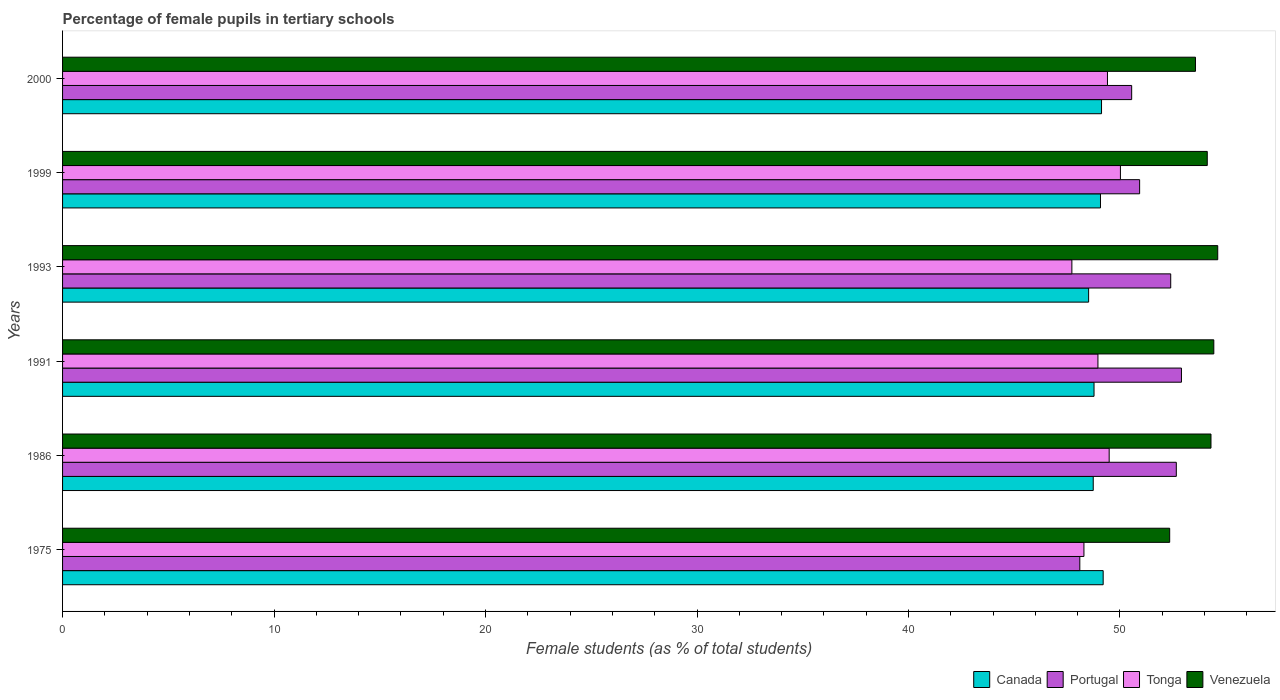How many bars are there on the 6th tick from the top?
Your answer should be compact. 4. How many bars are there on the 6th tick from the bottom?
Ensure brevity in your answer.  4. What is the label of the 4th group of bars from the top?
Provide a short and direct response. 1991. What is the percentage of female pupils in tertiary schools in Tonga in 1991?
Provide a succinct answer. 48.96. Across all years, what is the maximum percentage of female pupils in tertiary schools in Portugal?
Offer a terse response. 52.91. Across all years, what is the minimum percentage of female pupils in tertiary schools in Portugal?
Your answer should be very brief. 48.1. In which year was the percentage of female pupils in tertiary schools in Tonga maximum?
Give a very brief answer. 1999. In which year was the percentage of female pupils in tertiary schools in Tonga minimum?
Your answer should be very brief. 1993. What is the total percentage of female pupils in tertiary schools in Tonga in the graph?
Provide a succinct answer. 293.89. What is the difference between the percentage of female pupils in tertiary schools in Portugal in 1975 and that in 1991?
Make the answer very short. -4.81. What is the difference between the percentage of female pupils in tertiary schools in Tonga in 2000 and the percentage of female pupils in tertiary schools in Portugal in 1999?
Your answer should be compact. -1.52. What is the average percentage of female pupils in tertiary schools in Tonga per year?
Your answer should be compact. 48.98. In the year 1993, what is the difference between the percentage of female pupils in tertiary schools in Tonga and percentage of female pupils in tertiary schools in Canada?
Provide a short and direct response. -0.79. In how many years, is the percentage of female pupils in tertiary schools in Venezuela greater than 22 %?
Ensure brevity in your answer.  6. What is the ratio of the percentage of female pupils in tertiary schools in Portugal in 1991 to that in 1999?
Provide a succinct answer. 1.04. Is the percentage of female pupils in tertiary schools in Venezuela in 1975 less than that in 1991?
Provide a succinct answer. Yes. Is the difference between the percentage of female pupils in tertiary schools in Tonga in 1991 and 1993 greater than the difference between the percentage of female pupils in tertiary schools in Canada in 1991 and 1993?
Provide a succinct answer. Yes. What is the difference between the highest and the second highest percentage of female pupils in tertiary schools in Canada?
Ensure brevity in your answer.  0.08. What is the difference between the highest and the lowest percentage of female pupils in tertiary schools in Canada?
Keep it short and to the point. 0.69. Is the sum of the percentage of female pupils in tertiary schools in Venezuela in 1975 and 2000 greater than the maximum percentage of female pupils in tertiary schools in Canada across all years?
Your answer should be compact. Yes. Is it the case that in every year, the sum of the percentage of female pupils in tertiary schools in Portugal and percentage of female pupils in tertiary schools in Canada is greater than the sum of percentage of female pupils in tertiary schools in Venezuela and percentage of female pupils in tertiary schools in Tonga?
Give a very brief answer. Yes. What does the 2nd bar from the top in 2000 represents?
Offer a very short reply. Tonga. What does the 4th bar from the bottom in 1993 represents?
Offer a terse response. Venezuela. How many bars are there?
Keep it short and to the point. 24. What is the difference between two consecutive major ticks on the X-axis?
Your response must be concise. 10. Are the values on the major ticks of X-axis written in scientific E-notation?
Your answer should be compact. No. Does the graph contain grids?
Offer a very short reply. No. Where does the legend appear in the graph?
Provide a succinct answer. Bottom right. How many legend labels are there?
Your response must be concise. 4. What is the title of the graph?
Your answer should be very brief. Percentage of female pupils in tertiary schools. Does "South Africa" appear as one of the legend labels in the graph?
Your response must be concise. No. What is the label or title of the X-axis?
Offer a very short reply. Female students (as % of total students). What is the Female students (as % of total students) of Canada in 1975?
Provide a short and direct response. 49.21. What is the Female students (as % of total students) of Portugal in 1975?
Your answer should be very brief. 48.1. What is the Female students (as % of total students) in Tonga in 1975?
Ensure brevity in your answer.  48.3. What is the Female students (as % of total students) of Venezuela in 1975?
Keep it short and to the point. 52.35. What is the Female students (as % of total students) of Canada in 1986?
Ensure brevity in your answer.  48.74. What is the Female students (as % of total students) of Portugal in 1986?
Offer a terse response. 52.66. What is the Female students (as % of total students) of Tonga in 1986?
Your response must be concise. 49.49. What is the Female students (as % of total students) of Venezuela in 1986?
Provide a succinct answer. 54.3. What is the Female students (as % of total students) of Canada in 1991?
Offer a terse response. 48.77. What is the Female students (as % of total students) in Portugal in 1991?
Your answer should be compact. 52.91. What is the Female students (as % of total students) in Tonga in 1991?
Your response must be concise. 48.96. What is the Female students (as % of total students) in Venezuela in 1991?
Make the answer very short. 54.44. What is the Female students (as % of total students) of Canada in 1993?
Your answer should be very brief. 48.52. What is the Female students (as % of total students) in Portugal in 1993?
Keep it short and to the point. 52.4. What is the Female students (as % of total students) in Tonga in 1993?
Your answer should be very brief. 47.72. What is the Female students (as % of total students) of Venezuela in 1993?
Provide a succinct answer. 54.62. What is the Female students (as % of total students) in Canada in 1999?
Ensure brevity in your answer.  49.08. What is the Female students (as % of total students) in Portugal in 1999?
Offer a terse response. 50.93. What is the Female students (as % of total students) in Tonga in 1999?
Offer a very short reply. 50.02. What is the Female students (as % of total students) in Venezuela in 1999?
Keep it short and to the point. 54.13. What is the Female students (as % of total students) in Canada in 2000?
Offer a very short reply. 49.13. What is the Female students (as % of total students) of Portugal in 2000?
Provide a succinct answer. 50.55. What is the Female students (as % of total students) of Tonga in 2000?
Your answer should be very brief. 49.41. What is the Female students (as % of total students) of Venezuela in 2000?
Your answer should be very brief. 53.57. Across all years, what is the maximum Female students (as % of total students) in Canada?
Keep it short and to the point. 49.21. Across all years, what is the maximum Female students (as % of total students) of Portugal?
Give a very brief answer. 52.91. Across all years, what is the maximum Female students (as % of total students) of Tonga?
Give a very brief answer. 50.02. Across all years, what is the maximum Female students (as % of total students) of Venezuela?
Provide a short and direct response. 54.62. Across all years, what is the minimum Female students (as % of total students) of Canada?
Offer a terse response. 48.52. Across all years, what is the minimum Female students (as % of total students) of Portugal?
Offer a terse response. 48.1. Across all years, what is the minimum Female students (as % of total students) in Tonga?
Your answer should be compact. 47.72. Across all years, what is the minimum Female students (as % of total students) of Venezuela?
Give a very brief answer. 52.35. What is the total Female students (as % of total students) in Canada in the graph?
Your answer should be very brief. 293.44. What is the total Female students (as % of total students) in Portugal in the graph?
Provide a short and direct response. 307.55. What is the total Female students (as % of total students) in Tonga in the graph?
Provide a succinct answer. 293.89. What is the total Female students (as % of total students) of Venezuela in the graph?
Provide a succinct answer. 323.41. What is the difference between the Female students (as % of total students) in Canada in 1975 and that in 1986?
Offer a terse response. 0.47. What is the difference between the Female students (as % of total students) in Portugal in 1975 and that in 1986?
Provide a succinct answer. -4.56. What is the difference between the Female students (as % of total students) of Tonga in 1975 and that in 1986?
Ensure brevity in your answer.  -1.19. What is the difference between the Female students (as % of total students) in Venezuela in 1975 and that in 1986?
Make the answer very short. -1.95. What is the difference between the Female students (as % of total students) in Canada in 1975 and that in 1991?
Offer a terse response. 0.43. What is the difference between the Female students (as % of total students) of Portugal in 1975 and that in 1991?
Provide a succinct answer. -4.81. What is the difference between the Female students (as % of total students) of Tonga in 1975 and that in 1991?
Provide a succinct answer. -0.66. What is the difference between the Female students (as % of total students) in Venezuela in 1975 and that in 1991?
Give a very brief answer. -2.09. What is the difference between the Female students (as % of total students) in Canada in 1975 and that in 1993?
Offer a very short reply. 0.69. What is the difference between the Female students (as % of total students) of Portugal in 1975 and that in 1993?
Give a very brief answer. -4.3. What is the difference between the Female students (as % of total students) of Tonga in 1975 and that in 1993?
Offer a terse response. 0.57. What is the difference between the Female students (as % of total students) in Venezuela in 1975 and that in 1993?
Provide a short and direct response. -2.27. What is the difference between the Female students (as % of total students) of Canada in 1975 and that in 1999?
Your response must be concise. 0.13. What is the difference between the Female students (as % of total students) in Portugal in 1975 and that in 1999?
Provide a succinct answer. -2.83. What is the difference between the Female students (as % of total students) of Tonga in 1975 and that in 1999?
Ensure brevity in your answer.  -1.73. What is the difference between the Female students (as % of total students) in Venezuela in 1975 and that in 1999?
Your answer should be compact. -1.78. What is the difference between the Female students (as % of total students) in Canada in 1975 and that in 2000?
Offer a very short reply. 0.08. What is the difference between the Female students (as % of total students) of Portugal in 1975 and that in 2000?
Offer a terse response. -2.45. What is the difference between the Female students (as % of total students) of Tonga in 1975 and that in 2000?
Provide a short and direct response. -1.11. What is the difference between the Female students (as % of total students) of Venezuela in 1975 and that in 2000?
Make the answer very short. -1.22. What is the difference between the Female students (as % of total students) in Canada in 1986 and that in 1991?
Keep it short and to the point. -0.04. What is the difference between the Female students (as % of total students) in Portugal in 1986 and that in 1991?
Keep it short and to the point. -0.24. What is the difference between the Female students (as % of total students) in Tonga in 1986 and that in 1991?
Offer a terse response. 0.53. What is the difference between the Female students (as % of total students) of Venezuela in 1986 and that in 1991?
Give a very brief answer. -0.13. What is the difference between the Female students (as % of total students) of Canada in 1986 and that in 1993?
Your answer should be compact. 0.22. What is the difference between the Female students (as % of total students) in Portugal in 1986 and that in 1993?
Your answer should be compact. 0.26. What is the difference between the Female students (as % of total students) in Tonga in 1986 and that in 1993?
Make the answer very short. 1.76. What is the difference between the Female students (as % of total students) of Venezuela in 1986 and that in 1993?
Offer a terse response. -0.32. What is the difference between the Female students (as % of total students) of Canada in 1986 and that in 1999?
Your response must be concise. -0.34. What is the difference between the Female students (as % of total students) of Portugal in 1986 and that in 1999?
Keep it short and to the point. 1.73. What is the difference between the Female students (as % of total students) in Tonga in 1986 and that in 1999?
Your answer should be very brief. -0.53. What is the difference between the Female students (as % of total students) in Venezuela in 1986 and that in 1999?
Give a very brief answer. 0.18. What is the difference between the Female students (as % of total students) of Canada in 1986 and that in 2000?
Provide a short and direct response. -0.39. What is the difference between the Female students (as % of total students) of Portugal in 1986 and that in 2000?
Offer a terse response. 2.11. What is the difference between the Female students (as % of total students) in Tonga in 1986 and that in 2000?
Provide a succinct answer. 0.08. What is the difference between the Female students (as % of total students) in Venezuela in 1986 and that in 2000?
Offer a very short reply. 0.73. What is the difference between the Female students (as % of total students) of Canada in 1991 and that in 1993?
Your answer should be very brief. 0.26. What is the difference between the Female students (as % of total students) of Portugal in 1991 and that in 1993?
Give a very brief answer. 0.51. What is the difference between the Female students (as % of total students) of Tonga in 1991 and that in 1993?
Your answer should be compact. 1.23. What is the difference between the Female students (as % of total students) in Venezuela in 1991 and that in 1993?
Provide a short and direct response. -0.19. What is the difference between the Female students (as % of total students) in Canada in 1991 and that in 1999?
Offer a very short reply. -0.3. What is the difference between the Female students (as % of total students) in Portugal in 1991 and that in 1999?
Offer a terse response. 1.98. What is the difference between the Female students (as % of total students) in Tonga in 1991 and that in 1999?
Your answer should be compact. -1.06. What is the difference between the Female students (as % of total students) of Venezuela in 1991 and that in 1999?
Offer a very short reply. 0.31. What is the difference between the Female students (as % of total students) of Canada in 1991 and that in 2000?
Keep it short and to the point. -0.36. What is the difference between the Female students (as % of total students) of Portugal in 1991 and that in 2000?
Your answer should be very brief. 2.35. What is the difference between the Female students (as % of total students) of Tonga in 1991 and that in 2000?
Give a very brief answer. -0.45. What is the difference between the Female students (as % of total students) in Venezuela in 1991 and that in 2000?
Give a very brief answer. 0.87. What is the difference between the Female students (as % of total students) in Canada in 1993 and that in 1999?
Offer a terse response. -0.56. What is the difference between the Female students (as % of total students) in Portugal in 1993 and that in 1999?
Provide a short and direct response. 1.47. What is the difference between the Female students (as % of total students) of Tonga in 1993 and that in 1999?
Your answer should be compact. -2.3. What is the difference between the Female students (as % of total students) in Venezuela in 1993 and that in 1999?
Keep it short and to the point. 0.49. What is the difference between the Female students (as % of total students) of Canada in 1993 and that in 2000?
Ensure brevity in your answer.  -0.61. What is the difference between the Female students (as % of total students) in Portugal in 1993 and that in 2000?
Offer a terse response. 1.85. What is the difference between the Female students (as % of total students) of Tonga in 1993 and that in 2000?
Ensure brevity in your answer.  -1.68. What is the difference between the Female students (as % of total students) in Venezuela in 1993 and that in 2000?
Offer a terse response. 1.05. What is the difference between the Female students (as % of total students) of Canada in 1999 and that in 2000?
Offer a very short reply. -0.05. What is the difference between the Female students (as % of total students) of Portugal in 1999 and that in 2000?
Ensure brevity in your answer.  0.38. What is the difference between the Female students (as % of total students) of Tonga in 1999 and that in 2000?
Keep it short and to the point. 0.61. What is the difference between the Female students (as % of total students) in Venezuela in 1999 and that in 2000?
Ensure brevity in your answer.  0.56. What is the difference between the Female students (as % of total students) of Canada in 1975 and the Female students (as % of total students) of Portugal in 1986?
Provide a succinct answer. -3.46. What is the difference between the Female students (as % of total students) of Canada in 1975 and the Female students (as % of total students) of Tonga in 1986?
Your answer should be very brief. -0.28. What is the difference between the Female students (as % of total students) in Canada in 1975 and the Female students (as % of total students) in Venezuela in 1986?
Your response must be concise. -5.1. What is the difference between the Female students (as % of total students) of Portugal in 1975 and the Female students (as % of total students) of Tonga in 1986?
Your response must be concise. -1.39. What is the difference between the Female students (as % of total students) of Portugal in 1975 and the Female students (as % of total students) of Venezuela in 1986?
Your answer should be compact. -6.2. What is the difference between the Female students (as % of total students) in Tonga in 1975 and the Female students (as % of total students) in Venezuela in 1986?
Provide a short and direct response. -6.01. What is the difference between the Female students (as % of total students) of Canada in 1975 and the Female students (as % of total students) of Portugal in 1991?
Ensure brevity in your answer.  -3.7. What is the difference between the Female students (as % of total students) in Canada in 1975 and the Female students (as % of total students) in Tonga in 1991?
Give a very brief answer. 0.25. What is the difference between the Female students (as % of total students) of Canada in 1975 and the Female students (as % of total students) of Venezuela in 1991?
Your answer should be very brief. -5.23. What is the difference between the Female students (as % of total students) in Portugal in 1975 and the Female students (as % of total students) in Tonga in 1991?
Provide a short and direct response. -0.86. What is the difference between the Female students (as % of total students) of Portugal in 1975 and the Female students (as % of total students) of Venezuela in 1991?
Ensure brevity in your answer.  -6.34. What is the difference between the Female students (as % of total students) of Tonga in 1975 and the Female students (as % of total students) of Venezuela in 1991?
Ensure brevity in your answer.  -6.14. What is the difference between the Female students (as % of total students) in Canada in 1975 and the Female students (as % of total students) in Portugal in 1993?
Give a very brief answer. -3.19. What is the difference between the Female students (as % of total students) of Canada in 1975 and the Female students (as % of total students) of Tonga in 1993?
Make the answer very short. 1.48. What is the difference between the Female students (as % of total students) in Canada in 1975 and the Female students (as % of total students) in Venezuela in 1993?
Give a very brief answer. -5.42. What is the difference between the Female students (as % of total students) of Portugal in 1975 and the Female students (as % of total students) of Tonga in 1993?
Give a very brief answer. 0.38. What is the difference between the Female students (as % of total students) of Portugal in 1975 and the Female students (as % of total students) of Venezuela in 1993?
Give a very brief answer. -6.52. What is the difference between the Female students (as % of total students) in Tonga in 1975 and the Female students (as % of total students) in Venezuela in 1993?
Keep it short and to the point. -6.33. What is the difference between the Female students (as % of total students) in Canada in 1975 and the Female students (as % of total students) in Portugal in 1999?
Offer a terse response. -1.72. What is the difference between the Female students (as % of total students) of Canada in 1975 and the Female students (as % of total students) of Tonga in 1999?
Provide a succinct answer. -0.81. What is the difference between the Female students (as % of total students) in Canada in 1975 and the Female students (as % of total students) in Venezuela in 1999?
Keep it short and to the point. -4.92. What is the difference between the Female students (as % of total students) of Portugal in 1975 and the Female students (as % of total students) of Tonga in 1999?
Offer a terse response. -1.92. What is the difference between the Female students (as % of total students) in Portugal in 1975 and the Female students (as % of total students) in Venezuela in 1999?
Your response must be concise. -6.03. What is the difference between the Female students (as % of total students) of Tonga in 1975 and the Female students (as % of total students) of Venezuela in 1999?
Keep it short and to the point. -5.83. What is the difference between the Female students (as % of total students) of Canada in 1975 and the Female students (as % of total students) of Portugal in 2000?
Give a very brief answer. -1.35. What is the difference between the Female students (as % of total students) of Canada in 1975 and the Female students (as % of total students) of Tonga in 2000?
Your answer should be compact. -0.2. What is the difference between the Female students (as % of total students) of Canada in 1975 and the Female students (as % of total students) of Venezuela in 2000?
Offer a terse response. -4.36. What is the difference between the Female students (as % of total students) in Portugal in 1975 and the Female students (as % of total students) in Tonga in 2000?
Your answer should be compact. -1.31. What is the difference between the Female students (as % of total students) in Portugal in 1975 and the Female students (as % of total students) in Venezuela in 2000?
Your response must be concise. -5.47. What is the difference between the Female students (as % of total students) of Tonga in 1975 and the Female students (as % of total students) of Venezuela in 2000?
Ensure brevity in your answer.  -5.27. What is the difference between the Female students (as % of total students) of Canada in 1986 and the Female students (as % of total students) of Portugal in 1991?
Keep it short and to the point. -4.17. What is the difference between the Female students (as % of total students) in Canada in 1986 and the Female students (as % of total students) in Tonga in 1991?
Your answer should be very brief. -0.22. What is the difference between the Female students (as % of total students) in Canada in 1986 and the Female students (as % of total students) in Venezuela in 1991?
Keep it short and to the point. -5.7. What is the difference between the Female students (as % of total students) in Portugal in 1986 and the Female students (as % of total students) in Tonga in 1991?
Provide a short and direct response. 3.71. What is the difference between the Female students (as % of total students) of Portugal in 1986 and the Female students (as % of total students) of Venezuela in 1991?
Offer a very short reply. -1.77. What is the difference between the Female students (as % of total students) of Tonga in 1986 and the Female students (as % of total students) of Venezuela in 1991?
Your response must be concise. -4.95. What is the difference between the Female students (as % of total students) of Canada in 1986 and the Female students (as % of total students) of Portugal in 1993?
Your answer should be compact. -3.66. What is the difference between the Female students (as % of total students) of Canada in 1986 and the Female students (as % of total students) of Tonga in 1993?
Offer a very short reply. 1.01. What is the difference between the Female students (as % of total students) of Canada in 1986 and the Female students (as % of total students) of Venezuela in 1993?
Your answer should be compact. -5.89. What is the difference between the Female students (as % of total students) in Portugal in 1986 and the Female students (as % of total students) in Tonga in 1993?
Provide a short and direct response. 4.94. What is the difference between the Female students (as % of total students) in Portugal in 1986 and the Female students (as % of total students) in Venezuela in 1993?
Give a very brief answer. -1.96. What is the difference between the Female students (as % of total students) in Tonga in 1986 and the Female students (as % of total students) in Venezuela in 1993?
Your answer should be compact. -5.13. What is the difference between the Female students (as % of total students) in Canada in 1986 and the Female students (as % of total students) in Portugal in 1999?
Make the answer very short. -2.19. What is the difference between the Female students (as % of total students) of Canada in 1986 and the Female students (as % of total students) of Tonga in 1999?
Offer a very short reply. -1.29. What is the difference between the Female students (as % of total students) of Canada in 1986 and the Female students (as % of total students) of Venezuela in 1999?
Make the answer very short. -5.39. What is the difference between the Female students (as % of total students) in Portugal in 1986 and the Female students (as % of total students) in Tonga in 1999?
Offer a terse response. 2.64. What is the difference between the Female students (as % of total students) in Portugal in 1986 and the Female students (as % of total students) in Venezuela in 1999?
Make the answer very short. -1.46. What is the difference between the Female students (as % of total students) in Tonga in 1986 and the Female students (as % of total students) in Venezuela in 1999?
Offer a terse response. -4.64. What is the difference between the Female students (as % of total students) of Canada in 1986 and the Female students (as % of total students) of Portugal in 2000?
Offer a very short reply. -1.82. What is the difference between the Female students (as % of total students) in Canada in 1986 and the Female students (as % of total students) in Tonga in 2000?
Keep it short and to the point. -0.67. What is the difference between the Female students (as % of total students) of Canada in 1986 and the Female students (as % of total students) of Venezuela in 2000?
Your answer should be very brief. -4.83. What is the difference between the Female students (as % of total students) in Portugal in 1986 and the Female students (as % of total students) in Tonga in 2000?
Keep it short and to the point. 3.26. What is the difference between the Female students (as % of total students) in Portugal in 1986 and the Female students (as % of total students) in Venezuela in 2000?
Ensure brevity in your answer.  -0.91. What is the difference between the Female students (as % of total students) in Tonga in 1986 and the Female students (as % of total students) in Venezuela in 2000?
Provide a short and direct response. -4.08. What is the difference between the Female students (as % of total students) of Canada in 1991 and the Female students (as % of total students) of Portugal in 1993?
Make the answer very short. -3.63. What is the difference between the Female students (as % of total students) in Canada in 1991 and the Female students (as % of total students) in Tonga in 1993?
Offer a very short reply. 1.05. What is the difference between the Female students (as % of total students) in Canada in 1991 and the Female students (as % of total students) in Venezuela in 1993?
Provide a short and direct response. -5.85. What is the difference between the Female students (as % of total students) of Portugal in 1991 and the Female students (as % of total students) of Tonga in 1993?
Keep it short and to the point. 5.18. What is the difference between the Female students (as % of total students) of Portugal in 1991 and the Female students (as % of total students) of Venezuela in 1993?
Make the answer very short. -1.72. What is the difference between the Female students (as % of total students) of Tonga in 1991 and the Female students (as % of total students) of Venezuela in 1993?
Make the answer very short. -5.66. What is the difference between the Female students (as % of total students) of Canada in 1991 and the Female students (as % of total students) of Portugal in 1999?
Ensure brevity in your answer.  -2.16. What is the difference between the Female students (as % of total students) of Canada in 1991 and the Female students (as % of total students) of Tonga in 1999?
Keep it short and to the point. -1.25. What is the difference between the Female students (as % of total students) in Canada in 1991 and the Female students (as % of total students) in Venezuela in 1999?
Provide a short and direct response. -5.35. What is the difference between the Female students (as % of total students) in Portugal in 1991 and the Female students (as % of total students) in Tonga in 1999?
Your answer should be very brief. 2.89. What is the difference between the Female students (as % of total students) of Portugal in 1991 and the Female students (as % of total students) of Venezuela in 1999?
Your answer should be very brief. -1.22. What is the difference between the Female students (as % of total students) in Tonga in 1991 and the Female students (as % of total students) in Venezuela in 1999?
Your answer should be compact. -5.17. What is the difference between the Female students (as % of total students) of Canada in 1991 and the Female students (as % of total students) of Portugal in 2000?
Ensure brevity in your answer.  -1.78. What is the difference between the Female students (as % of total students) of Canada in 1991 and the Female students (as % of total students) of Tonga in 2000?
Your answer should be very brief. -0.64. What is the difference between the Female students (as % of total students) in Canada in 1991 and the Female students (as % of total students) in Venezuela in 2000?
Your answer should be very brief. -4.8. What is the difference between the Female students (as % of total students) of Portugal in 1991 and the Female students (as % of total students) of Tonga in 2000?
Provide a succinct answer. 3.5. What is the difference between the Female students (as % of total students) in Portugal in 1991 and the Female students (as % of total students) in Venezuela in 2000?
Your response must be concise. -0.66. What is the difference between the Female students (as % of total students) of Tonga in 1991 and the Female students (as % of total students) of Venezuela in 2000?
Provide a succinct answer. -4.61. What is the difference between the Female students (as % of total students) in Canada in 1993 and the Female students (as % of total students) in Portugal in 1999?
Give a very brief answer. -2.41. What is the difference between the Female students (as % of total students) of Canada in 1993 and the Female students (as % of total students) of Tonga in 1999?
Your response must be concise. -1.5. What is the difference between the Female students (as % of total students) in Canada in 1993 and the Female students (as % of total students) in Venezuela in 1999?
Keep it short and to the point. -5.61. What is the difference between the Female students (as % of total students) of Portugal in 1993 and the Female students (as % of total students) of Tonga in 1999?
Your response must be concise. 2.38. What is the difference between the Female students (as % of total students) in Portugal in 1993 and the Female students (as % of total students) in Venezuela in 1999?
Your answer should be very brief. -1.73. What is the difference between the Female students (as % of total students) of Tonga in 1993 and the Female students (as % of total students) of Venezuela in 1999?
Your answer should be very brief. -6.4. What is the difference between the Female students (as % of total students) of Canada in 1993 and the Female students (as % of total students) of Portugal in 2000?
Your answer should be compact. -2.03. What is the difference between the Female students (as % of total students) in Canada in 1993 and the Female students (as % of total students) in Tonga in 2000?
Provide a succinct answer. -0.89. What is the difference between the Female students (as % of total students) of Canada in 1993 and the Female students (as % of total students) of Venezuela in 2000?
Provide a short and direct response. -5.05. What is the difference between the Female students (as % of total students) in Portugal in 1993 and the Female students (as % of total students) in Tonga in 2000?
Provide a short and direct response. 2.99. What is the difference between the Female students (as % of total students) of Portugal in 1993 and the Female students (as % of total students) of Venezuela in 2000?
Give a very brief answer. -1.17. What is the difference between the Female students (as % of total students) of Tonga in 1993 and the Female students (as % of total students) of Venezuela in 2000?
Your answer should be compact. -5.84. What is the difference between the Female students (as % of total students) in Canada in 1999 and the Female students (as % of total students) in Portugal in 2000?
Your answer should be very brief. -1.47. What is the difference between the Female students (as % of total students) in Canada in 1999 and the Female students (as % of total students) in Tonga in 2000?
Your answer should be very brief. -0.33. What is the difference between the Female students (as % of total students) of Canada in 1999 and the Female students (as % of total students) of Venezuela in 2000?
Offer a terse response. -4.49. What is the difference between the Female students (as % of total students) of Portugal in 1999 and the Female students (as % of total students) of Tonga in 2000?
Offer a terse response. 1.52. What is the difference between the Female students (as % of total students) in Portugal in 1999 and the Female students (as % of total students) in Venezuela in 2000?
Offer a very short reply. -2.64. What is the difference between the Female students (as % of total students) of Tonga in 1999 and the Female students (as % of total students) of Venezuela in 2000?
Keep it short and to the point. -3.55. What is the average Female students (as % of total students) of Canada per year?
Your response must be concise. 48.91. What is the average Female students (as % of total students) of Portugal per year?
Provide a succinct answer. 51.26. What is the average Female students (as % of total students) in Tonga per year?
Provide a short and direct response. 48.98. What is the average Female students (as % of total students) of Venezuela per year?
Offer a very short reply. 53.9. In the year 1975, what is the difference between the Female students (as % of total students) of Canada and Female students (as % of total students) of Portugal?
Make the answer very short. 1.1. In the year 1975, what is the difference between the Female students (as % of total students) of Canada and Female students (as % of total students) of Tonga?
Ensure brevity in your answer.  0.91. In the year 1975, what is the difference between the Female students (as % of total students) of Canada and Female students (as % of total students) of Venezuela?
Ensure brevity in your answer.  -3.14. In the year 1975, what is the difference between the Female students (as % of total students) of Portugal and Female students (as % of total students) of Tonga?
Your answer should be very brief. -0.2. In the year 1975, what is the difference between the Female students (as % of total students) in Portugal and Female students (as % of total students) in Venezuela?
Offer a very short reply. -4.25. In the year 1975, what is the difference between the Female students (as % of total students) of Tonga and Female students (as % of total students) of Venezuela?
Keep it short and to the point. -4.05. In the year 1986, what is the difference between the Female students (as % of total students) in Canada and Female students (as % of total students) in Portugal?
Keep it short and to the point. -3.93. In the year 1986, what is the difference between the Female students (as % of total students) in Canada and Female students (as % of total students) in Tonga?
Give a very brief answer. -0.75. In the year 1986, what is the difference between the Female students (as % of total students) in Canada and Female students (as % of total students) in Venezuela?
Your answer should be compact. -5.57. In the year 1986, what is the difference between the Female students (as % of total students) in Portugal and Female students (as % of total students) in Tonga?
Provide a succinct answer. 3.17. In the year 1986, what is the difference between the Female students (as % of total students) of Portugal and Female students (as % of total students) of Venezuela?
Provide a short and direct response. -1.64. In the year 1986, what is the difference between the Female students (as % of total students) in Tonga and Female students (as % of total students) in Venezuela?
Keep it short and to the point. -4.81. In the year 1991, what is the difference between the Female students (as % of total students) in Canada and Female students (as % of total students) in Portugal?
Offer a very short reply. -4.13. In the year 1991, what is the difference between the Female students (as % of total students) in Canada and Female students (as % of total students) in Tonga?
Make the answer very short. -0.19. In the year 1991, what is the difference between the Female students (as % of total students) in Canada and Female students (as % of total students) in Venezuela?
Keep it short and to the point. -5.66. In the year 1991, what is the difference between the Female students (as % of total students) of Portugal and Female students (as % of total students) of Tonga?
Your answer should be very brief. 3.95. In the year 1991, what is the difference between the Female students (as % of total students) in Portugal and Female students (as % of total students) in Venezuela?
Keep it short and to the point. -1.53. In the year 1991, what is the difference between the Female students (as % of total students) in Tonga and Female students (as % of total students) in Venezuela?
Provide a succinct answer. -5.48. In the year 1993, what is the difference between the Female students (as % of total students) of Canada and Female students (as % of total students) of Portugal?
Give a very brief answer. -3.88. In the year 1993, what is the difference between the Female students (as % of total students) in Canada and Female students (as % of total students) in Tonga?
Provide a succinct answer. 0.79. In the year 1993, what is the difference between the Female students (as % of total students) of Canada and Female students (as % of total students) of Venezuela?
Give a very brief answer. -6.1. In the year 1993, what is the difference between the Female students (as % of total students) in Portugal and Female students (as % of total students) in Tonga?
Offer a terse response. 4.67. In the year 1993, what is the difference between the Female students (as % of total students) of Portugal and Female students (as % of total students) of Venezuela?
Keep it short and to the point. -2.22. In the year 1993, what is the difference between the Female students (as % of total students) of Tonga and Female students (as % of total students) of Venezuela?
Your response must be concise. -6.9. In the year 1999, what is the difference between the Female students (as % of total students) in Canada and Female students (as % of total students) in Portugal?
Offer a very short reply. -1.85. In the year 1999, what is the difference between the Female students (as % of total students) of Canada and Female students (as % of total students) of Tonga?
Give a very brief answer. -0.94. In the year 1999, what is the difference between the Female students (as % of total students) in Canada and Female students (as % of total students) in Venezuela?
Provide a succinct answer. -5.05. In the year 1999, what is the difference between the Female students (as % of total students) in Portugal and Female students (as % of total students) in Tonga?
Give a very brief answer. 0.91. In the year 1999, what is the difference between the Female students (as % of total students) in Portugal and Female students (as % of total students) in Venezuela?
Make the answer very short. -3.2. In the year 1999, what is the difference between the Female students (as % of total students) of Tonga and Female students (as % of total students) of Venezuela?
Give a very brief answer. -4.11. In the year 2000, what is the difference between the Female students (as % of total students) of Canada and Female students (as % of total students) of Portugal?
Your answer should be compact. -1.42. In the year 2000, what is the difference between the Female students (as % of total students) in Canada and Female students (as % of total students) in Tonga?
Make the answer very short. -0.28. In the year 2000, what is the difference between the Female students (as % of total students) in Canada and Female students (as % of total students) in Venezuela?
Keep it short and to the point. -4.44. In the year 2000, what is the difference between the Female students (as % of total students) of Portugal and Female students (as % of total students) of Tonga?
Your answer should be very brief. 1.14. In the year 2000, what is the difference between the Female students (as % of total students) in Portugal and Female students (as % of total students) in Venezuela?
Make the answer very short. -3.02. In the year 2000, what is the difference between the Female students (as % of total students) of Tonga and Female students (as % of total students) of Venezuela?
Provide a short and direct response. -4.16. What is the ratio of the Female students (as % of total students) of Canada in 1975 to that in 1986?
Ensure brevity in your answer.  1.01. What is the ratio of the Female students (as % of total students) in Portugal in 1975 to that in 1986?
Your answer should be very brief. 0.91. What is the ratio of the Female students (as % of total students) in Tonga in 1975 to that in 1986?
Your answer should be very brief. 0.98. What is the ratio of the Female students (as % of total students) of Canada in 1975 to that in 1991?
Your response must be concise. 1.01. What is the ratio of the Female students (as % of total students) of Portugal in 1975 to that in 1991?
Your answer should be compact. 0.91. What is the ratio of the Female students (as % of total students) in Tonga in 1975 to that in 1991?
Your response must be concise. 0.99. What is the ratio of the Female students (as % of total students) in Venezuela in 1975 to that in 1991?
Give a very brief answer. 0.96. What is the ratio of the Female students (as % of total students) in Canada in 1975 to that in 1993?
Offer a terse response. 1.01. What is the ratio of the Female students (as % of total students) of Portugal in 1975 to that in 1993?
Offer a terse response. 0.92. What is the ratio of the Female students (as % of total students) in Tonga in 1975 to that in 1993?
Offer a terse response. 1.01. What is the ratio of the Female students (as % of total students) in Venezuela in 1975 to that in 1993?
Your answer should be very brief. 0.96. What is the ratio of the Female students (as % of total students) in Portugal in 1975 to that in 1999?
Make the answer very short. 0.94. What is the ratio of the Female students (as % of total students) of Tonga in 1975 to that in 1999?
Your response must be concise. 0.97. What is the ratio of the Female students (as % of total students) of Venezuela in 1975 to that in 1999?
Offer a very short reply. 0.97. What is the ratio of the Female students (as % of total students) of Portugal in 1975 to that in 2000?
Your response must be concise. 0.95. What is the ratio of the Female students (as % of total students) of Tonga in 1975 to that in 2000?
Make the answer very short. 0.98. What is the ratio of the Female students (as % of total students) of Venezuela in 1975 to that in 2000?
Offer a terse response. 0.98. What is the ratio of the Female students (as % of total students) of Tonga in 1986 to that in 1991?
Provide a short and direct response. 1.01. What is the ratio of the Female students (as % of total students) of Portugal in 1986 to that in 1993?
Offer a very short reply. 1. What is the ratio of the Female students (as % of total students) of Canada in 1986 to that in 1999?
Your answer should be very brief. 0.99. What is the ratio of the Female students (as % of total students) of Portugal in 1986 to that in 1999?
Provide a succinct answer. 1.03. What is the ratio of the Female students (as % of total students) of Tonga in 1986 to that in 1999?
Provide a succinct answer. 0.99. What is the ratio of the Female students (as % of total students) of Portugal in 1986 to that in 2000?
Your answer should be very brief. 1.04. What is the ratio of the Female students (as % of total students) of Tonga in 1986 to that in 2000?
Your answer should be very brief. 1. What is the ratio of the Female students (as % of total students) of Venezuela in 1986 to that in 2000?
Ensure brevity in your answer.  1.01. What is the ratio of the Female students (as % of total students) in Portugal in 1991 to that in 1993?
Provide a succinct answer. 1.01. What is the ratio of the Female students (as % of total students) of Tonga in 1991 to that in 1993?
Keep it short and to the point. 1.03. What is the ratio of the Female students (as % of total students) in Venezuela in 1991 to that in 1993?
Your response must be concise. 1. What is the ratio of the Female students (as % of total students) in Canada in 1991 to that in 1999?
Offer a very short reply. 0.99. What is the ratio of the Female students (as % of total students) of Portugal in 1991 to that in 1999?
Your answer should be very brief. 1.04. What is the ratio of the Female students (as % of total students) in Tonga in 1991 to that in 1999?
Your answer should be compact. 0.98. What is the ratio of the Female students (as % of total students) in Portugal in 1991 to that in 2000?
Provide a short and direct response. 1.05. What is the ratio of the Female students (as % of total students) of Tonga in 1991 to that in 2000?
Provide a short and direct response. 0.99. What is the ratio of the Female students (as % of total students) of Venezuela in 1991 to that in 2000?
Offer a very short reply. 1.02. What is the ratio of the Female students (as % of total students) in Portugal in 1993 to that in 1999?
Your answer should be compact. 1.03. What is the ratio of the Female students (as % of total students) of Tonga in 1993 to that in 1999?
Provide a short and direct response. 0.95. What is the ratio of the Female students (as % of total students) in Venezuela in 1993 to that in 1999?
Provide a short and direct response. 1.01. What is the ratio of the Female students (as % of total students) in Canada in 1993 to that in 2000?
Your response must be concise. 0.99. What is the ratio of the Female students (as % of total students) in Portugal in 1993 to that in 2000?
Offer a terse response. 1.04. What is the ratio of the Female students (as % of total students) of Tonga in 1993 to that in 2000?
Make the answer very short. 0.97. What is the ratio of the Female students (as % of total students) in Venezuela in 1993 to that in 2000?
Make the answer very short. 1.02. What is the ratio of the Female students (as % of total students) of Portugal in 1999 to that in 2000?
Offer a terse response. 1.01. What is the ratio of the Female students (as % of total students) of Tonga in 1999 to that in 2000?
Your response must be concise. 1.01. What is the ratio of the Female students (as % of total students) in Venezuela in 1999 to that in 2000?
Keep it short and to the point. 1.01. What is the difference between the highest and the second highest Female students (as % of total students) in Canada?
Provide a short and direct response. 0.08. What is the difference between the highest and the second highest Female students (as % of total students) of Portugal?
Offer a very short reply. 0.24. What is the difference between the highest and the second highest Female students (as % of total students) of Tonga?
Offer a very short reply. 0.53. What is the difference between the highest and the second highest Female students (as % of total students) in Venezuela?
Keep it short and to the point. 0.19. What is the difference between the highest and the lowest Female students (as % of total students) in Canada?
Provide a succinct answer. 0.69. What is the difference between the highest and the lowest Female students (as % of total students) in Portugal?
Make the answer very short. 4.81. What is the difference between the highest and the lowest Female students (as % of total students) in Tonga?
Your answer should be compact. 2.3. What is the difference between the highest and the lowest Female students (as % of total students) of Venezuela?
Keep it short and to the point. 2.27. 